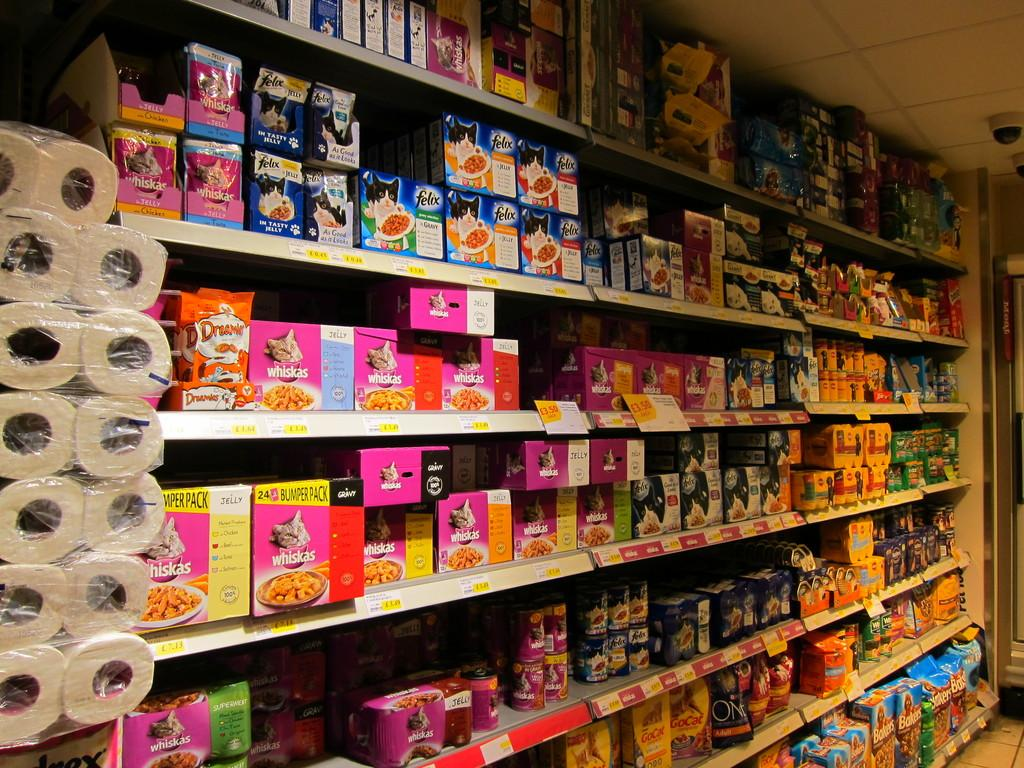<image>
Offer a succinct explanation of the picture presented. The pet food section of a small market has Whiskas, Felix, and ONE brands on the shelves. 